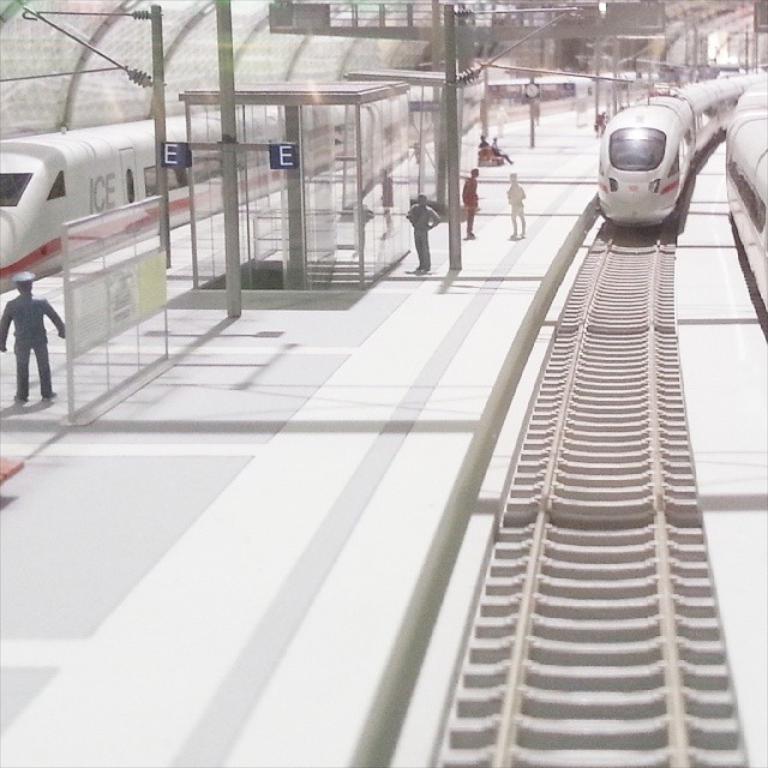What platform letter is this?
Make the answer very short. E. What is written on the train on the left?
Your response must be concise. Ice. 